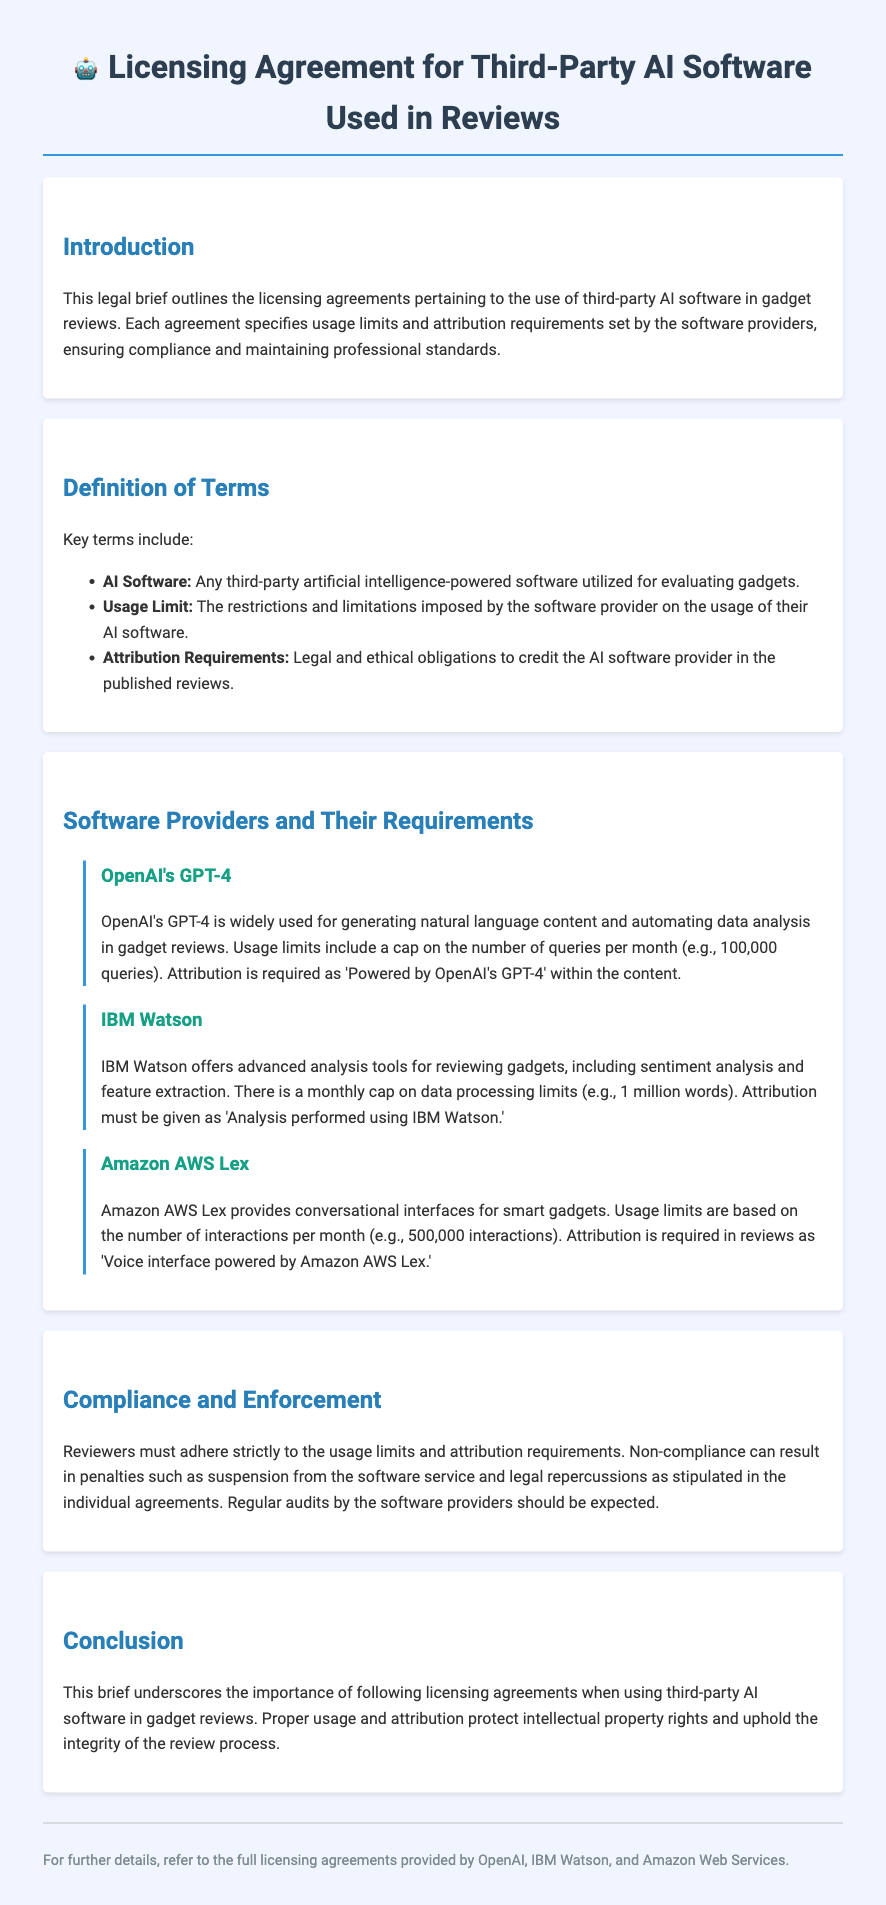What is the purpose of the legal brief? The introduction outlines the overall goal of the legal brief, which addresses the licensing agreements for third-party AI software in gadget reviews.
Answer: Licensing agreements for third-party AI software in gadget reviews What is the usage limit for OpenAI's GPT-4? The specific paragraph details the restrictions imposed by OpenAI on usage, which includes a cap on queries per month.
Answer: 100,000 queries What must be stated in attribution for IBM Watson? The document specifies the language that needs to be included to credit the IBM Watson software used in reviews.
Answer: Analysis performed using IBM Watson How many interactions per month does Amazon AWS Lex allow? The relevant section outlines the monthly limitations set by Amazon AWS Lex for usage in gadget reviews.
Answer: 500,000 interactions What is the consequence of non-compliance with the agreements? The brief discusses the penalties that may result from not adhering to the specified requirements of the licensing agreements.
Answer: Suspension from the software service What does the brief emphasize regarding usage and attribution? The conclusion summarizes the key takeaways from the document about the importance of proper usage and attribution in reviews.
Answer: Protect intellectual property rights What type of AI software is defined in the document? The definition of terms section includes a clear description of the software being discussed in the licensing agreements.
Answer: Third-party artificial intelligence-powered software What is the main focus of the compliance section? This section addresses the adherence to specified requirements and the potential consequences of failing to comply with the agreements.
Answer: Adhere to usage limits and attribution requirements 